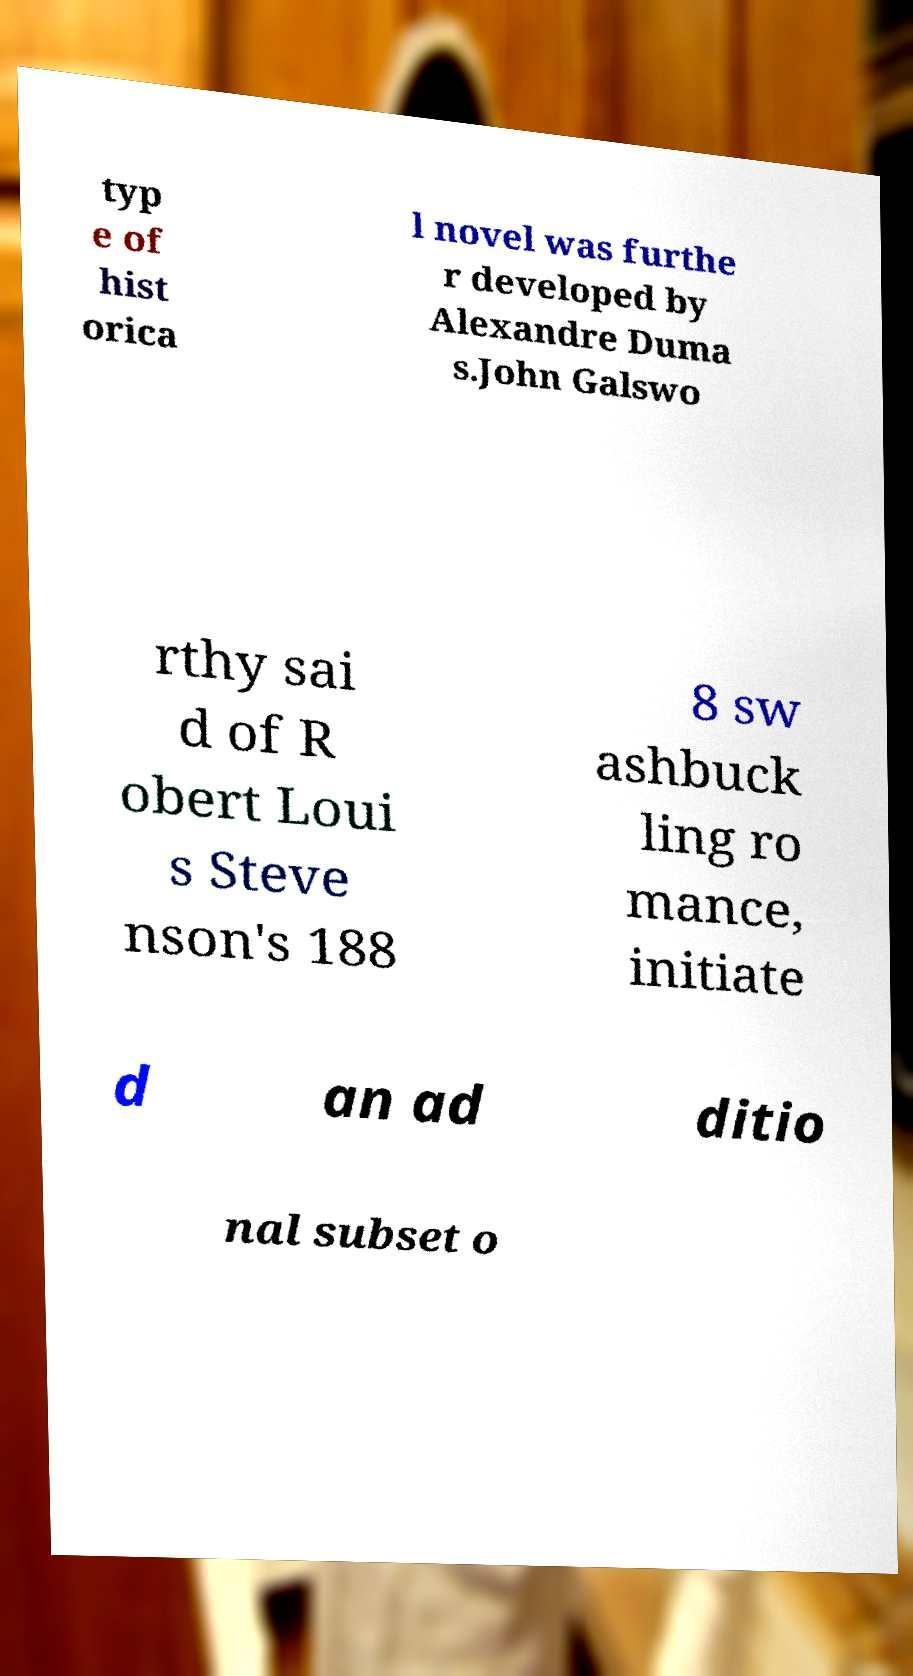For documentation purposes, I need the text within this image transcribed. Could you provide that? typ e of hist orica l novel was furthe r developed by Alexandre Duma s.John Galswo rthy sai d of R obert Loui s Steve nson's 188 8 sw ashbuck ling ro mance, initiate d an ad ditio nal subset o 